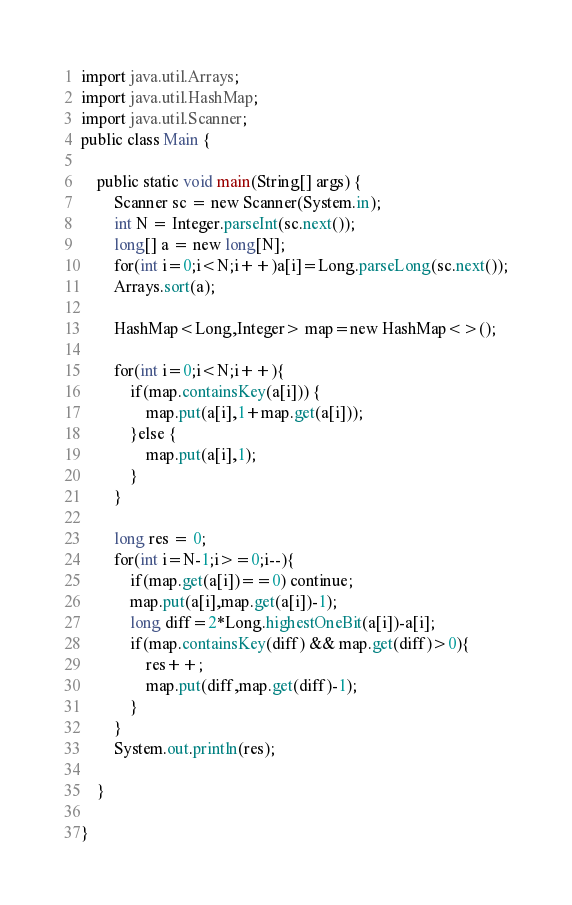Convert code to text. <code><loc_0><loc_0><loc_500><loc_500><_Java_>import java.util.Arrays;
import java.util.HashMap;
import java.util.Scanner;
public class Main {

	public static void main(String[] args) {
		Scanner sc = new Scanner(System.in);
		int N = Integer.parseInt(sc.next());
		long[] a = new long[N];
		for(int i=0;i<N;i++)a[i]=Long.parseLong(sc.next());
		Arrays.sort(a);

		HashMap<Long,Integer> map=new HashMap<>();
		
		for(int i=0;i<N;i++){
			if(map.containsKey(a[i])) {
				map.put(a[i],1+map.get(a[i]));
			}else {
				map.put(a[i],1);
			}
		}

		long res = 0;
		for(int i=N-1;i>=0;i--){
			if(map.get(a[i])==0) continue;
			map.put(a[i],map.get(a[i])-1);
			long diff=2*Long.highestOneBit(a[i])-a[i];
			if(map.containsKey(diff) && map.get(diff)>0){
				res++;
				map.put(diff,map.get(diff)-1);
			}
		}
		System.out.println(res);

	}

}</code> 